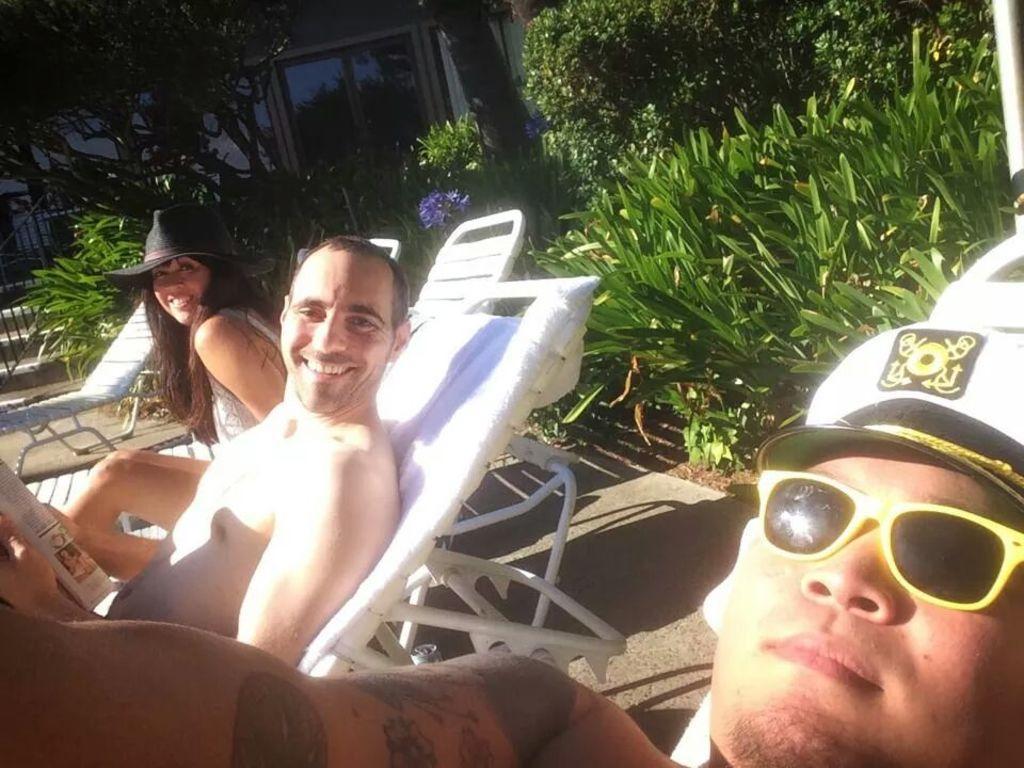Could you give a brief overview of what you see in this image? In this picture we can see three people sitting on chairs were two are smiling, caps, goggles, paper, trees, fence and in the background we can see glass doors. 